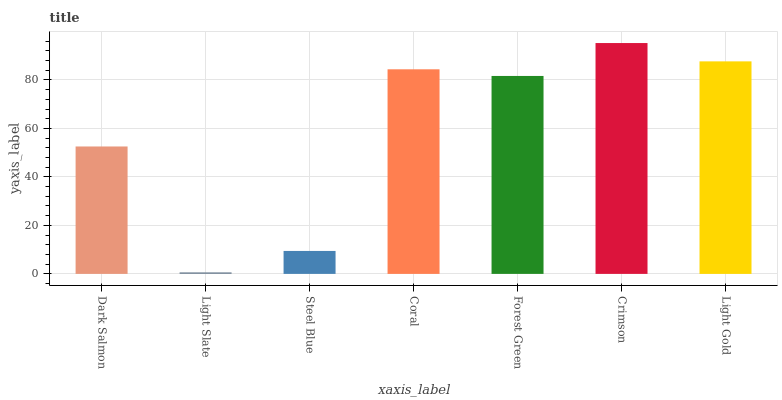Is Light Slate the minimum?
Answer yes or no. Yes. Is Crimson the maximum?
Answer yes or no. Yes. Is Steel Blue the minimum?
Answer yes or no. No. Is Steel Blue the maximum?
Answer yes or no. No. Is Steel Blue greater than Light Slate?
Answer yes or no. Yes. Is Light Slate less than Steel Blue?
Answer yes or no. Yes. Is Light Slate greater than Steel Blue?
Answer yes or no. No. Is Steel Blue less than Light Slate?
Answer yes or no. No. Is Forest Green the high median?
Answer yes or no. Yes. Is Forest Green the low median?
Answer yes or no. Yes. Is Crimson the high median?
Answer yes or no. No. Is Steel Blue the low median?
Answer yes or no. No. 